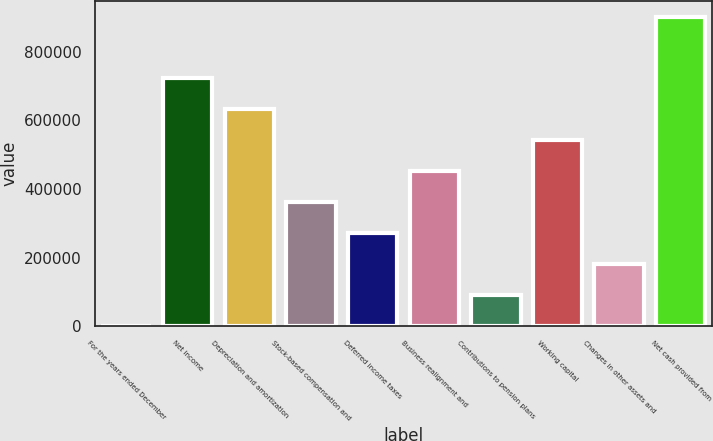Convert chart. <chart><loc_0><loc_0><loc_500><loc_500><bar_chart><fcel>For the years ended December<fcel>Net income<fcel>Depreciation and amortization<fcel>Stock-based compensation and<fcel>Deferred income taxes<fcel>Business realignment and<fcel>Contributions to pension plans<fcel>Working capital<fcel>Changes in other assets and<fcel>Net cash provided from<nl><fcel>2010<fcel>721540<fcel>631599<fcel>361775<fcel>271834<fcel>451716<fcel>91951.3<fcel>541658<fcel>181893<fcel>901423<nl></chart> 